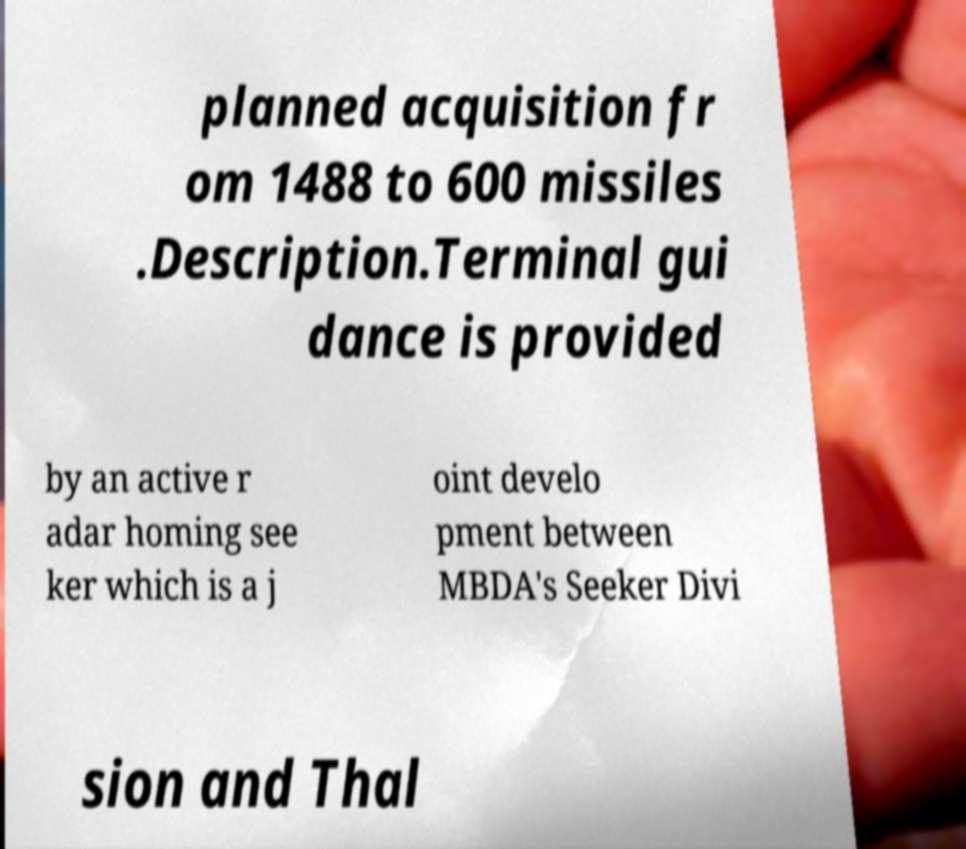What messages or text are displayed in this image? I need them in a readable, typed format. planned acquisition fr om 1488 to 600 missiles .Description.Terminal gui dance is provided by an active r adar homing see ker which is a j oint develo pment between MBDA's Seeker Divi sion and Thal 